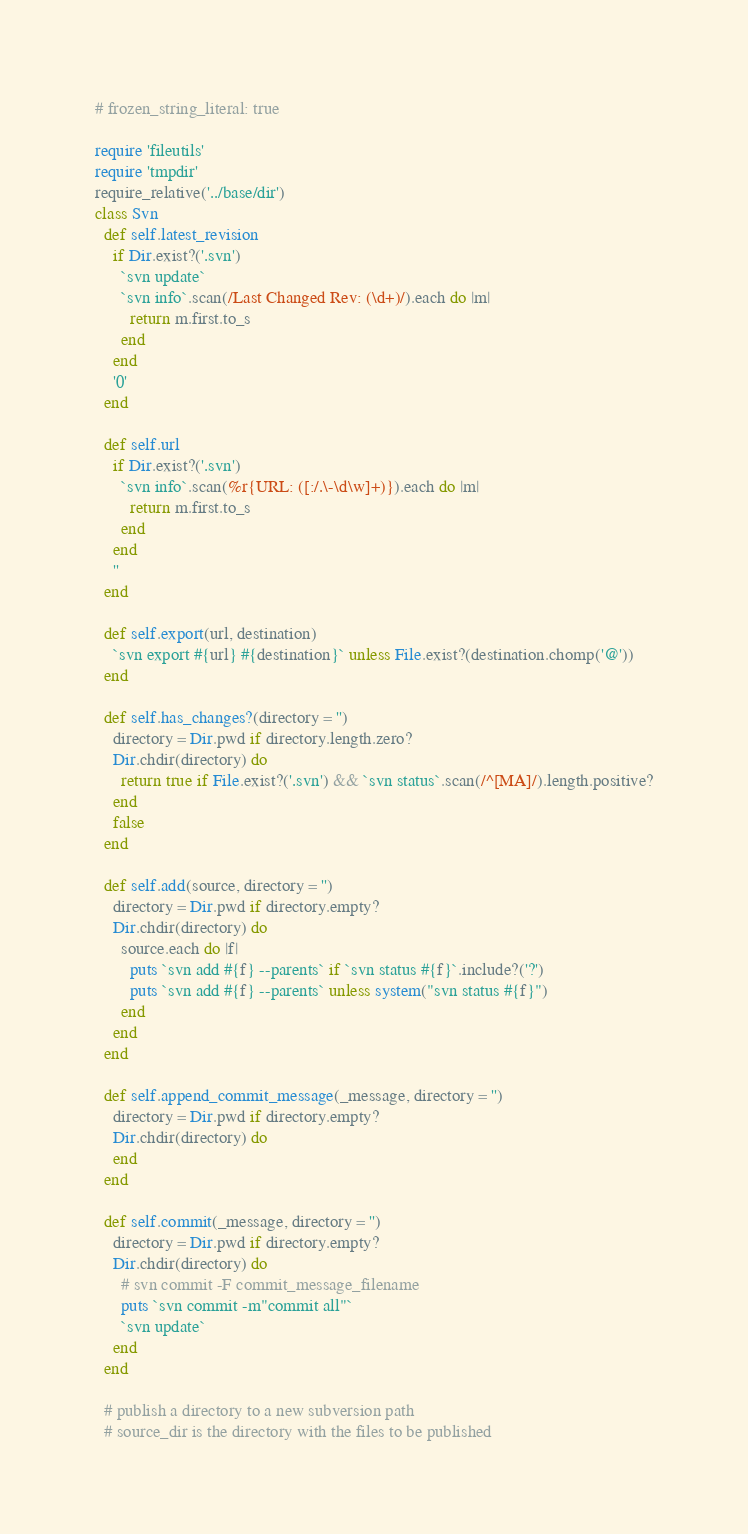<code> <loc_0><loc_0><loc_500><loc_500><_Ruby_># frozen_string_literal: true

require 'fileutils'
require 'tmpdir'
require_relative('../base/dir')
class Svn
  def self.latest_revision
    if Dir.exist?('.svn')
      `svn update`
      `svn info`.scan(/Last Changed Rev: (\d+)/).each do |m|
        return m.first.to_s
      end
    end
    '0'
  end

  def self.url
    if Dir.exist?('.svn')
      `svn info`.scan(%r{URL: ([:/.\-\d\w]+)}).each do |m|
        return m.first.to_s
      end
    end
    ''
  end

  def self.export(url, destination)
    `svn export #{url} #{destination}` unless File.exist?(destination.chomp('@'))
  end

  def self.has_changes?(directory = '')
    directory = Dir.pwd if directory.length.zero?
    Dir.chdir(directory) do
      return true if File.exist?('.svn') && `svn status`.scan(/^[MA]/).length.positive?
    end
    false
  end

  def self.add(source, directory = '')
    directory = Dir.pwd if directory.empty?
    Dir.chdir(directory) do
      source.each do |f|
        puts `svn add #{f} --parents` if `svn status #{f}`.include?('?')
        puts `svn add #{f} --parents` unless system("svn status #{f}")
      end
    end
  end

  def self.append_commit_message(_message, directory = '')
    directory = Dir.pwd if directory.empty?
    Dir.chdir(directory) do
    end
  end

  def self.commit(_message, directory = '')
    directory = Dir.pwd if directory.empty?
    Dir.chdir(directory) do
      # svn commit -F commit_message_filename
      puts `svn commit -m"commit all"`
      `svn update`
    end
  end

  # publish a directory to a new subversion path
  # source_dir is the directory with the files to be published</code> 